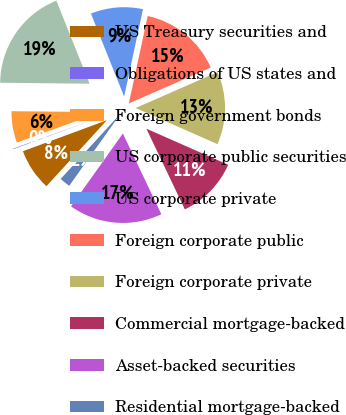<chart> <loc_0><loc_0><loc_500><loc_500><pie_chart><fcel>US Treasury securities and<fcel>Obligations of US states and<fcel>Foreign government bonds<fcel>US corporate public securities<fcel>US corporate private<fcel>Foreign corporate public<fcel>Foreign corporate private<fcel>Commercial mortgage-backed<fcel>Asset-backed securities<fcel>Residential mortgage-backed<nl><fcel>7.57%<fcel>0.09%<fcel>5.7%<fcel>18.78%<fcel>9.44%<fcel>15.05%<fcel>13.18%<fcel>11.31%<fcel>16.92%<fcel>1.96%<nl></chart> 